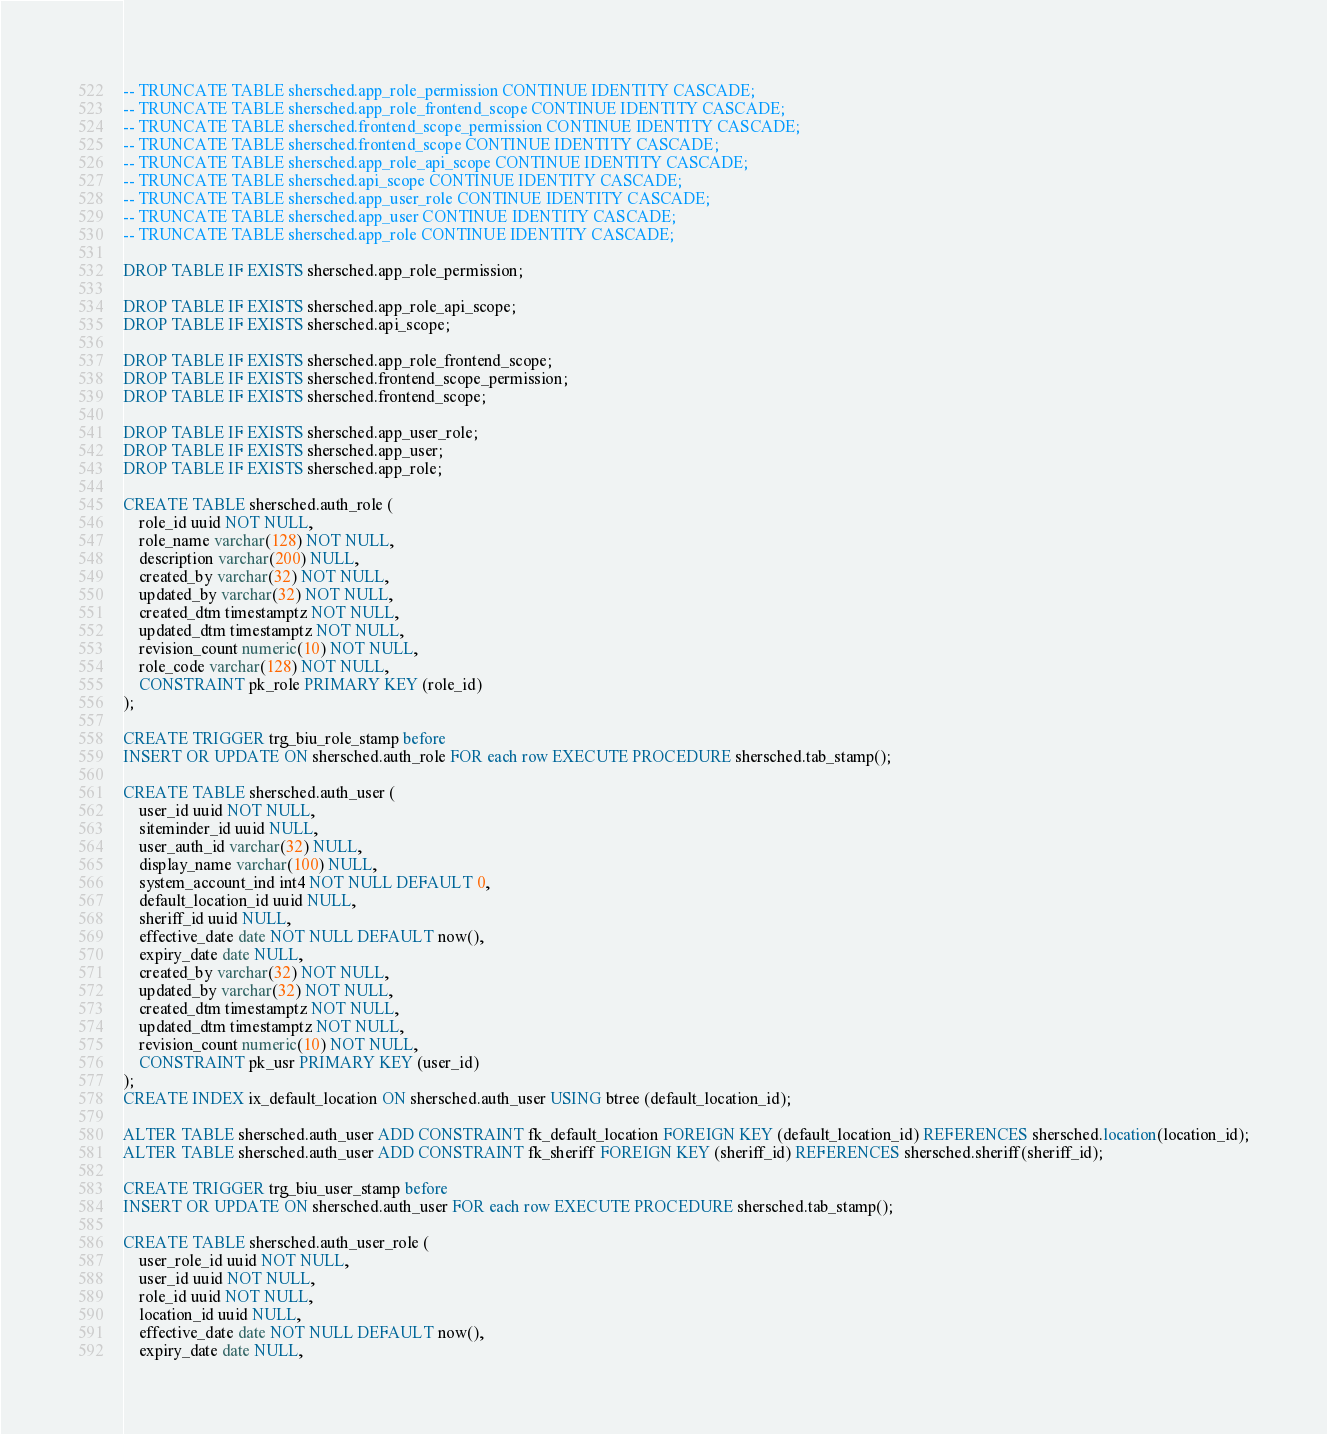<code> <loc_0><loc_0><loc_500><loc_500><_SQL_>-- TRUNCATE TABLE shersched.app_role_permission CONTINUE IDENTITY CASCADE;
-- TRUNCATE TABLE shersched.app_role_frontend_scope CONTINUE IDENTITY CASCADE;
-- TRUNCATE TABLE shersched.frontend_scope_permission CONTINUE IDENTITY CASCADE;
-- TRUNCATE TABLE shersched.frontend_scope CONTINUE IDENTITY CASCADE;
-- TRUNCATE TABLE shersched.app_role_api_scope CONTINUE IDENTITY CASCADE;
-- TRUNCATE TABLE shersched.api_scope CONTINUE IDENTITY CASCADE;
-- TRUNCATE TABLE shersched.app_user_role CONTINUE IDENTITY CASCADE;
-- TRUNCATE TABLE shersched.app_user CONTINUE IDENTITY CASCADE;
-- TRUNCATE TABLE shersched.app_role CONTINUE IDENTITY CASCADE;

DROP TABLE IF EXISTS shersched.app_role_permission;

DROP TABLE IF EXISTS shersched.app_role_api_scope;
DROP TABLE IF EXISTS shersched.api_scope;

DROP TABLE IF EXISTS shersched.app_role_frontend_scope;
DROP TABLE IF EXISTS shersched.frontend_scope_permission;
DROP TABLE IF EXISTS shersched.frontend_scope;

DROP TABLE IF EXISTS shersched.app_user_role;
DROP TABLE IF EXISTS shersched.app_user;
DROP TABLE IF EXISTS shersched.app_role;

CREATE TABLE shersched.auth_role (
	role_id uuid NOT NULL,
	role_name varchar(128) NOT NULL,
	description varchar(200) NULL,
	created_by varchar(32) NOT NULL,
	updated_by varchar(32) NOT NULL,
	created_dtm timestamptz NOT NULL,
	updated_dtm timestamptz NOT NULL,
	revision_count numeric(10) NOT NULL,
	role_code varchar(128) NOT NULL,
	CONSTRAINT pk_role PRIMARY KEY (role_id)
);

CREATE TRIGGER trg_biu_role_stamp before
INSERT OR UPDATE ON shersched.auth_role FOR each row EXECUTE PROCEDURE shersched.tab_stamp();

CREATE TABLE shersched.auth_user (
	user_id uuid NOT NULL,
	siteminder_id uuid NULL,
	user_auth_id varchar(32) NULL,
	display_name varchar(100) NULL,
	system_account_ind int4 NOT NULL DEFAULT 0,
	default_location_id uuid NULL,
	sheriff_id uuid NULL,
	effective_date date NOT NULL DEFAULT now(),
	expiry_date date NULL,
	created_by varchar(32) NOT NULL,
	updated_by varchar(32) NOT NULL,
	created_dtm timestamptz NOT NULL,
	updated_dtm timestamptz NOT NULL,
	revision_count numeric(10) NOT NULL,
	CONSTRAINT pk_usr PRIMARY KEY (user_id)
);
CREATE INDEX ix_default_location ON shersched.auth_user USING btree (default_location_id);

ALTER TABLE shersched.auth_user ADD CONSTRAINT fk_default_location FOREIGN KEY (default_location_id) REFERENCES shersched.location(location_id);
ALTER TABLE shersched.auth_user ADD CONSTRAINT fk_sheriff FOREIGN KEY (sheriff_id) REFERENCES shersched.sheriff(sheriff_id);

CREATE TRIGGER trg_biu_user_stamp before
INSERT OR UPDATE ON shersched.auth_user FOR each row EXECUTE PROCEDURE shersched.tab_stamp();

CREATE TABLE shersched.auth_user_role (
	user_role_id uuid NOT NULL,
	user_id uuid NOT NULL,
	role_id uuid NOT NULL,
	location_id uuid NULL,
	effective_date date NOT NULL DEFAULT now(),
	expiry_date date NULL,</code> 